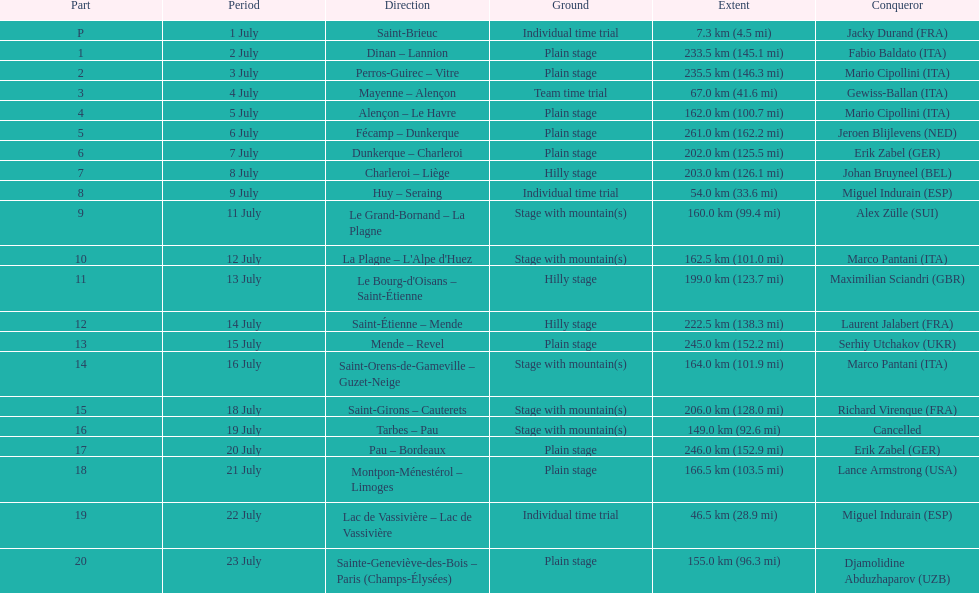Write the full table. {'header': ['Part', 'Period', 'Direction', 'Ground', 'Extent', 'Conqueror'], 'rows': [['P', '1 July', 'Saint-Brieuc', 'Individual time trial', '7.3\xa0km (4.5\xa0mi)', 'Jacky Durand\xa0(FRA)'], ['1', '2 July', 'Dinan – Lannion', 'Plain stage', '233.5\xa0km (145.1\xa0mi)', 'Fabio Baldato\xa0(ITA)'], ['2', '3 July', 'Perros-Guirec – Vitre', 'Plain stage', '235.5\xa0km (146.3\xa0mi)', 'Mario Cipollini\xa0(ITA)'], ['3', '4 July', 'Mayenne – Alençon', 'Team time trial', '67.0\xa0km (41.6\xa0mi)', 'Gewiss-Ballan\xa0(ITA)'], ['4', '5 July', 'Alençon – Le Havre', 'Plain stage', '162.0\xa0km (100.7\xa0mi)', 'Mario Cipollini\xa0(ITA)'], ['5', '6 July', 'Fécamp – Dunkerque', 'Plain stage', '261.0\xa0km (162.2\xa0mi)', 'Jeroen Blijlevens\xa0(NED)'], ['6', '7 July', 'Dunkerque – Charleroi', 'Plain stage', '202.0\xa0km (125.5\xa0mi)', 'Erik Zabel\xa0(GER)'], ['7', '8 July', 'Charleroi – Liège', 'Hilly stage', '203.0\xa0km (126.1\xa0mi)', 'Johan Bruyneel\xa0(BEL)'], ['8', '9 July', 'Huy – Seraing', 'Individual time trial', '54.0\xa0km (33.6\xa0mi)', 'Miguel Indurain\xa0(ESP)'], ['9', '11 July', 'Le Grand-Bornand – La Plagne', 'Stage with mountain(s)', '160.0\xa0km (99.4\xa0mi)', 'Alex Zülle\xa0(SUI)'], ['10', '12 July', "La Plagne – L'Alpe d'Huez", 'Stage with mountain(s)', '162.5\xa0km (101.0\xa0mi)', 'Marco Pantani\xa0(ITA)'], ['11', '13 July', "Le Bourg-d'Oisans – Saint-Étienne", 'Hilly stage', '199.0\xa0km (123.7\xa0mi)', 'Maximilian Sciandri\xa0(GBR)'], ['12', '14 July', 'Saint-Étienne – Mende', 'Hilly stage', '222.5\xa0km (138.3\xa0mi)', 'Laurent Jalabert\xa0(FRA)'], ['13', '15 July', 'Mende – Revel', 'Plain stage', '245.0\xa0km (152.2\xa0mi)', 'Serhiy Utchakov\xa0(UKR)'], ['14', '16 July', 'Saint-Orens-de-Gameville – Guzet-Neige', 'Stage with mountain(s)', '164.0\xa0km (101.9\xa0mi)', 'Marco Pantani\xa0(ITA)'], ['15', '18 July', 'Saint-Girons – Cauterets', 'Stage with mountain(s)', '206.0\xa0km (128.0\xa0mi)', 'Richard Virenque\xa0(FRA)'], ['16', '19 July', 'Tarbes – Pau', 'Stage with mountain(s)', '149.0\xa0km (92.6\xa0mi)', 'Cancelled'], ['17', '20 July', 'Pau – Bordeaux', 'Plain stage', '246.0\xa0km (152.9\xa0mi)', 'Erik Zabel\xa0(GER)'], ['18', '21 July', 'Montpon-Ménestérol – Limoges', 'Plain stage', '166.5\xa0km (103.5\xa0mi)', 'Lance Armstrong\xa0(USA)'], ['19', '22 July', 'Lac de Vassivière – Lac de Vassivière', 'Individual time trial', '46.5\xa0km (28.9\xa0mi)', 'Miguel Indurain\xa0(ESP)'], ['20', '23 July', 'Sainte-Geneviève-des-Bois – Paris (Champs-Élysées)', 'Plain stage', '155.0\xa0km (96.3\xa0mi)', 'Djamolidine Abduzhaparov\xa0(UZB)']]} How many consecutive km were raced on july 8th? 203.0 km (126.1 mi). 